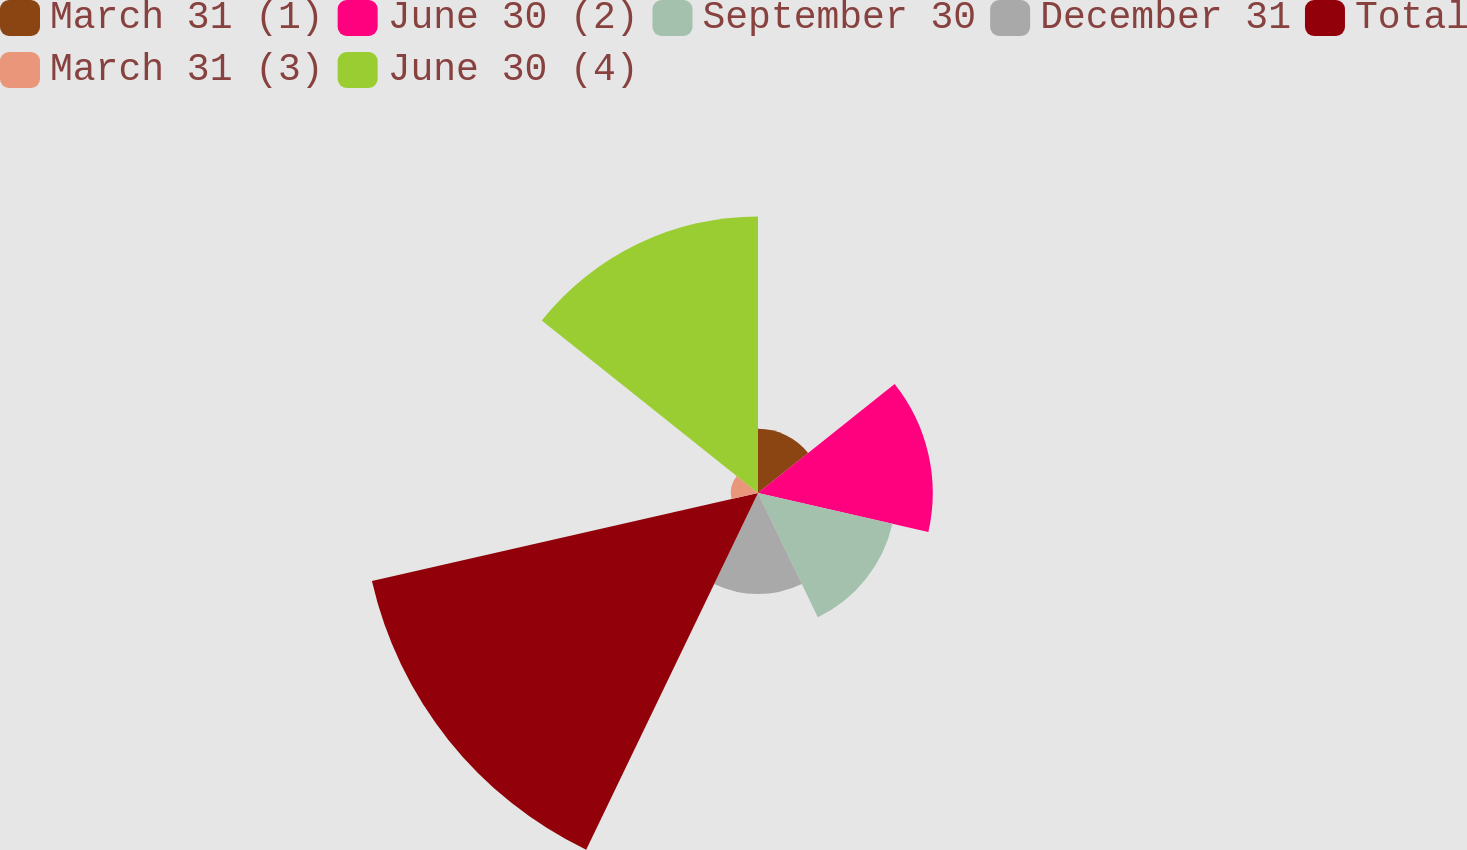Convert chart. <chart><loc_0><loc_0><loc_500><loc_500><pie_chart><fcel>March 31 (1)<fcel>June 30 (2)<fcel>September 30<fcel>December 31<fcel>Total<fcel>March 31 (3)<fcel>June 30 (4)<nl><fcel>5.45%<fcel>14.84%<fcel>11.71%<fcel>8.58%<fcel>33.63%<fcel>2.31%<fcel>23.49%<nl></chart> 